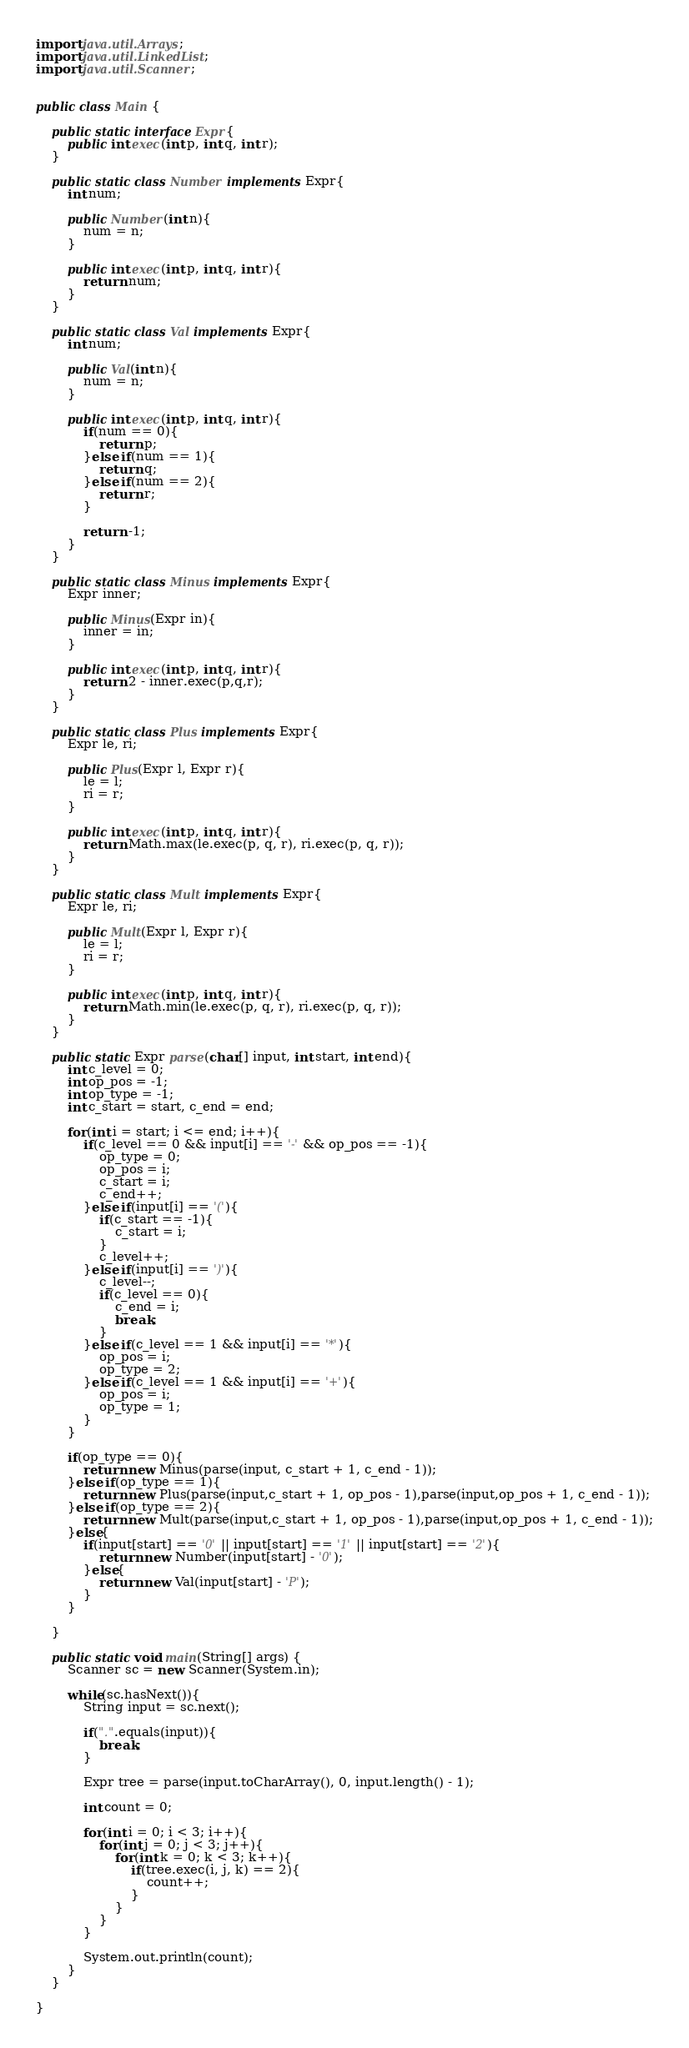<code> <loc_0><loc_0><loc_500><loc_500><_Java_>import java.util.Arrays;
import java.util.LinkedList;
import java.util.Scanner;


public class Main {
	
	public static interface Expr{
		public int exec(int p, int q, int r);
	}
	
	public static class Number implements Expr{
		int num;
		
		public Number(int n){
			num = n;
		}
		
		public int exec(int p, int q, int r){
			return num;
		}
	}
	
	public static class Val implements Expr{
		int num;
		
		public Val(int n){
			num = n;
		}
		
		public int exec(int p, int q, int r){
			if(num == 0){
				return p;
			}else if(num == 1){
				return q;
			}else if(num == 2){
				return r;
			}
			
			return -1;
		}
	}
	
	public static class Minus implements Expr{
		Expr inner;
		
		public Minus(Expr in){
			inner = in;
		}
		
		public int exec(int p, int q, int r){
			return 2 - inner.exec(p,q,r);
		}
	}
	
	public static class Plus implements Expr{
		Expr le, ri;
		
		public Plus(Expr l, Expr r){
			le = l;
			ri = r;
		}
		
		public int exec(int p, int q, int r){
			return Math.max(le.exec(p, q, r), ri.exec(p, q, r));
		}
	}
	
	public static class Mult implements Expr{
		Expr le, ri;
		
		public Mult(Expr l, Expr r){
			le = l;
			ri = r;
		}
		
		public int exec(int p, int q, int r){
			return Math.min(le.exec(p, q, r), ri.exec(p, q, r));
		}
	}
	
	public static Expr parse(char[] input, int start, int end){
		int c_level = 0;
		int op_pos = -1;
		int op_type = -1;
		int c_start = start, c_end = end;
		
		for(int i = start; i <= end; i++){
			if(c_level == 0 && input[i] == '-' && op_pos == -1){
				op_type = 0;
				op_pos = i;
				c_start = i;
				c_end++;
			}else if(input[i] == '('){
				if(c_start == -1){
					c_start = i;
				}
				c_level++;
			}else if(input[i] == ')'){
				c_level--;
				if(c_level == 0){
					c_end = i;
					break;
				}
			}else if(c_level == 1 && input[i] == '*'){
				op_pos = i;
				op_type = 2;
			}else if(c_level == 1 && input[i] == '+'){
				op_pos = i;
				op_type = 1;
			}
		}
		
		if(op_type == 0){
			return new Minus(parse(input, c_start + 1, c_end - 1));
		}else if(op_type == 1){
			return new Plus(parse(input,c_start + 1, op_pos - 1),parse(input,op_pos + 1, c_end - 1));
		}else if(op_type == 2){
			return new Mult(parse(input,c_start + 1, op_pos - 1),parse(input,op_pos + 1, c_end - 1));
		}else{
			if(input[start] == '0' || input[start] == '1' || input[start] == '2'){
				return new Number(input[start] - '0');
			}else{
				return new Val(input[start] - 'P');
			}
		}
		
	}
	
	public static void main(String[] args) {
		Scanner sc = new Scanner(System.in);
		
		while(sc.hasNext()){
			String input = sc.next();
			
			if(".".equals(input)){
				break;
			}
			
			Expr tree = parse(input.toCharArray(), 0, input.length() - 1);
			
			int count = 0;
			
			for(int i = 0; i < 3; i++){
				for(int j = 0; j < 3; j++){
					for(int k = 0; k < 3; k++){
						if(tree.exec(i, j, k) == 2){
							count++;
						}
					}
				}
			}
			
			System.out.println(count);
		}
	}

}</code> 